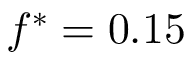Convert formula to latex. <formula><loc_0><loc_0><loc_500><loc_500>f ^ { * } = 0 . 1 5</formula> 